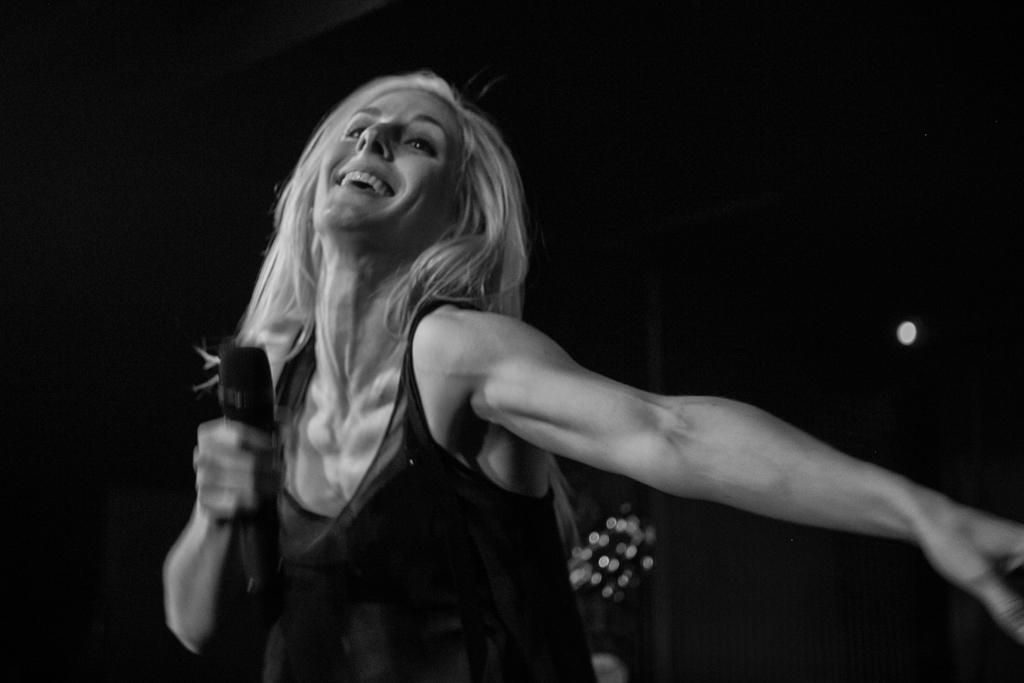Who is the main subject in the image? There is a woman in the image. What is the woman wearing? The woman is wearing a black dress. What is the woman holding in the image? The woman is holding a mic. Can you describe the background of the image? The background of the image is dark. What type of writing is the woman doing in the image? There is no writing activity depicted in the image; the woman is holding a mic. What type of trade is being conducted in the image? There is no trade activity depicted in the image; the woman is holding a mic. 